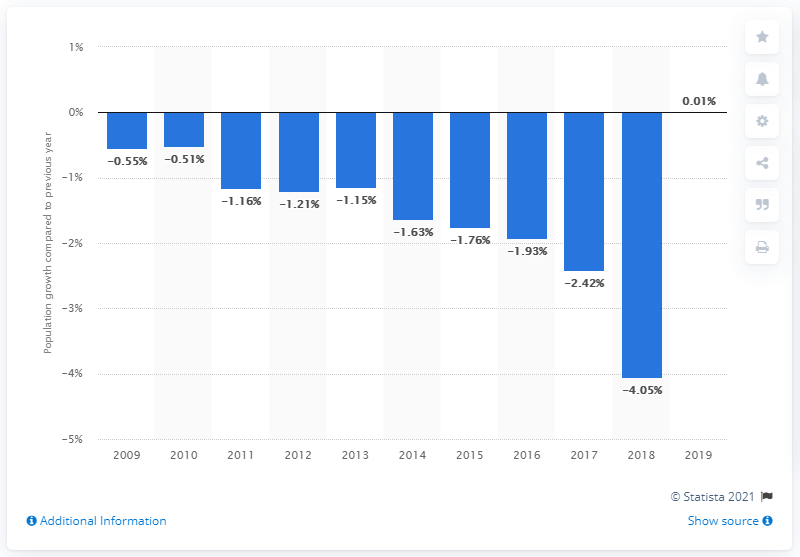Outline some significant characteristics in this image. Puerto Rico's population increased by 0.01% in 2019. 